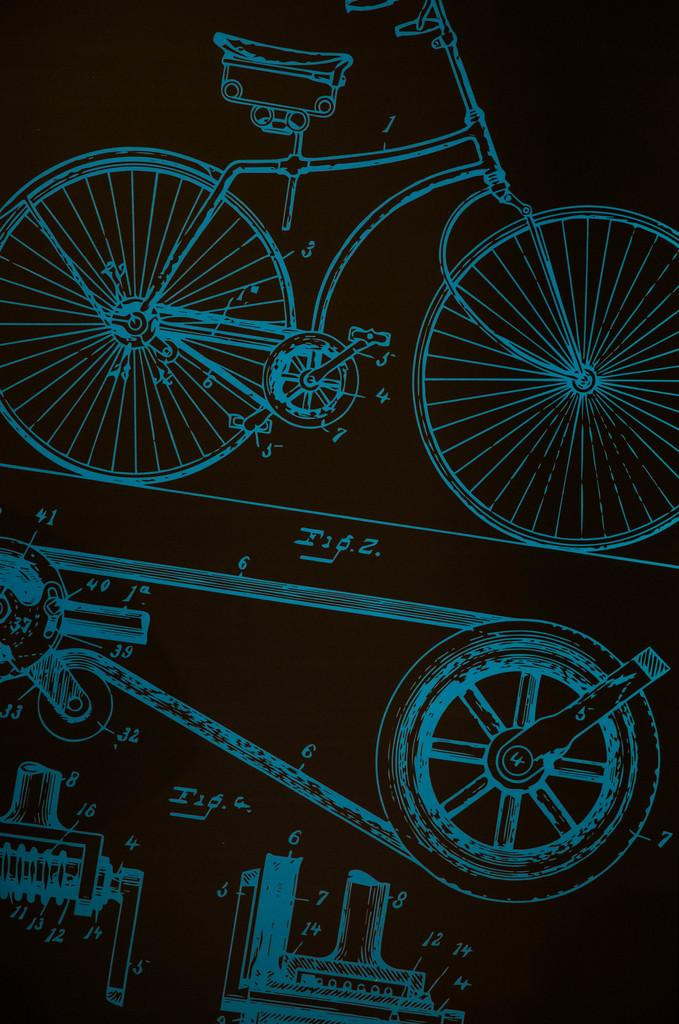What is the main subject of the paintings in the image? The main subject of the paintings in the image is bicycles. What specific elements of bicycles are depicted in the paintings? The paintings depict bicycle parts. Are there any additional elements included in the paintings? Yes, the paintings include numbers. What is the color of the background in the image? The background of the image is dark in color. Can you tell me how many tanks are visible in the image? There are no tanks present in the image; it features paintings of bicycles. What type of quilt is being used to cover the bicycle parts in the image? There is no quilt present in the image; it features paintings of bicycle parts with numbers. 